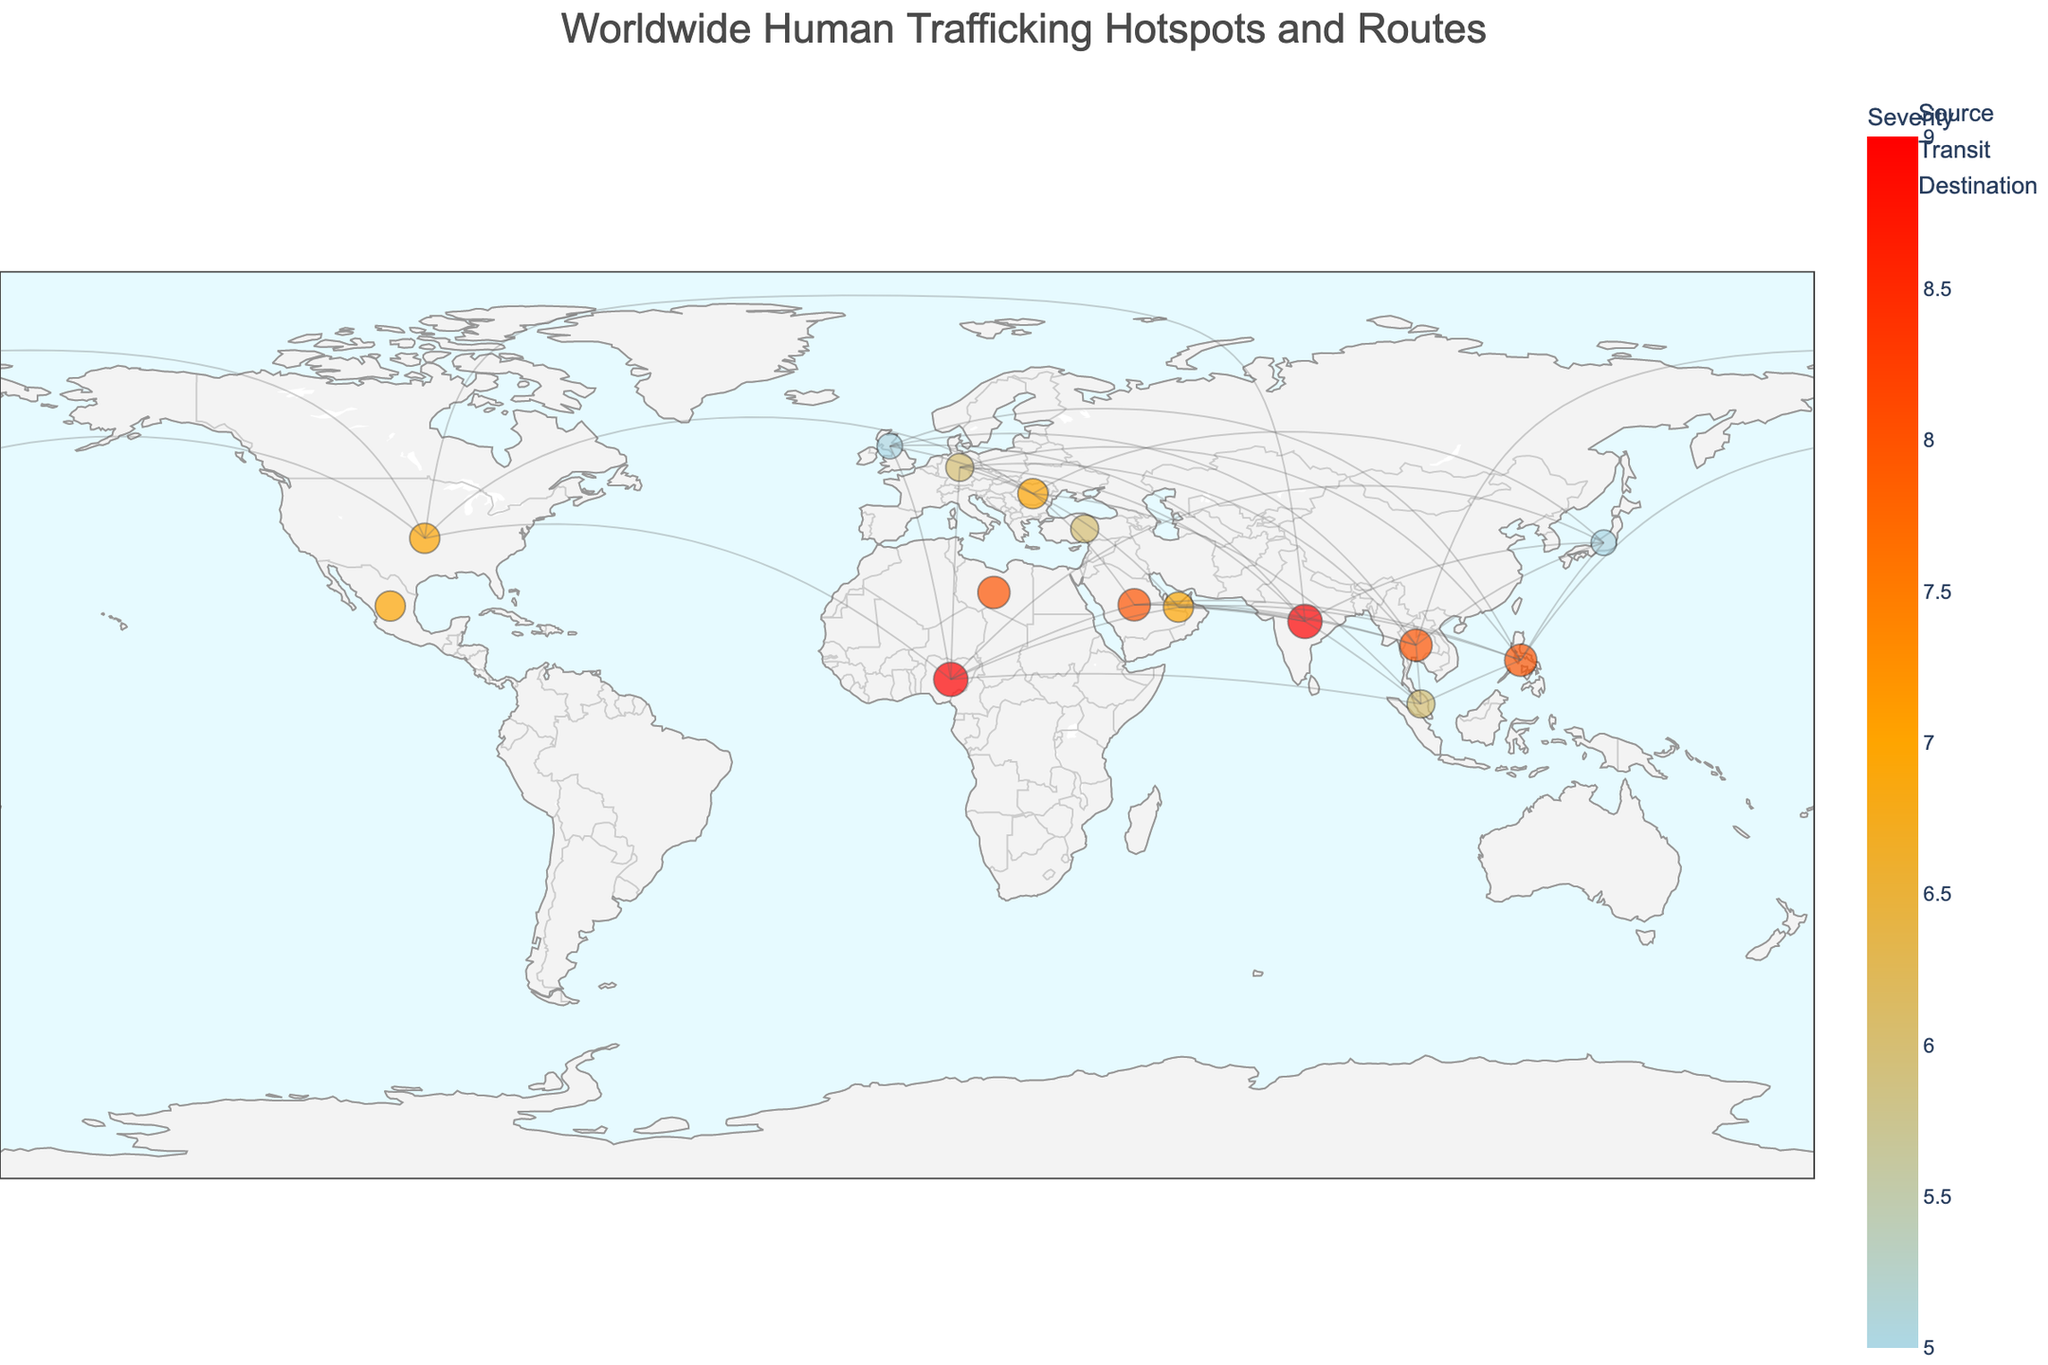What is the title of the geographic plot? The title of the plot is usually found at the top and summarizes the main topic of the plot. It helps the viewer understand what the map is about.
Answer: Worldwide Human Trafficking Hotspots and Routes Which country is the most severe source of human trafficking according to the plot? Severity can be determined by inspecting the size and color of the markers on the plot. The country with the highest severity marker among the source countries is the answer.
Answer: Nigeria and India How many countries in the plot are marked as transit countries? To determine this, count the number of markers labeled as "Transit" in the plot's legend or in the tooltip data.
Answer: 3 What are the severity levels assigned to destination countries? By looking at the different markers and their colors/sizes for destination countries, we can list their severities as indicated by the plot.
Answer: 5, 6, 7, 8 Which destination country has the highest severity in human trafficking? Identify the destination country with the largest and/or reddest marker, indicating the highest severity, among the destination countries.
Answer: Saudi Arabia How does the severity of human trafficking in the United States compare to that in Germany? Compare the marker size and color for the United States and Germany to determine which one has higher or lower severity.
Answer: The United States has a higher severity (7) compared to Germany (6) How many source countries are there, and what are they? Count the number of markers labeled as "Source" and identify these countries from the labels provided.
Answer: 5: Thailand, Nigeria, Romania, India, Philippines What types of countries are involved in human trafficking routes originating from Thailand based on the plot? Look at the arrows originating from Thailand and identify the types of destination countries they connect to (Source, Transit, Destination).
Answer: Destination countries Describe the relationship between human trafficking severity and marker size on the plot. Larger markers indicate higher severity levels. This relationship can be observed by comparing the size of markers across the plot.
Answer: Larger marker size indicates higher severity Which transit country has the highest severity, and what is its severity level? Identify the transit country with the largest/most colored marker, then note its severity as shown in the tooltip or legend.
Answer: Libya, Severity 8 